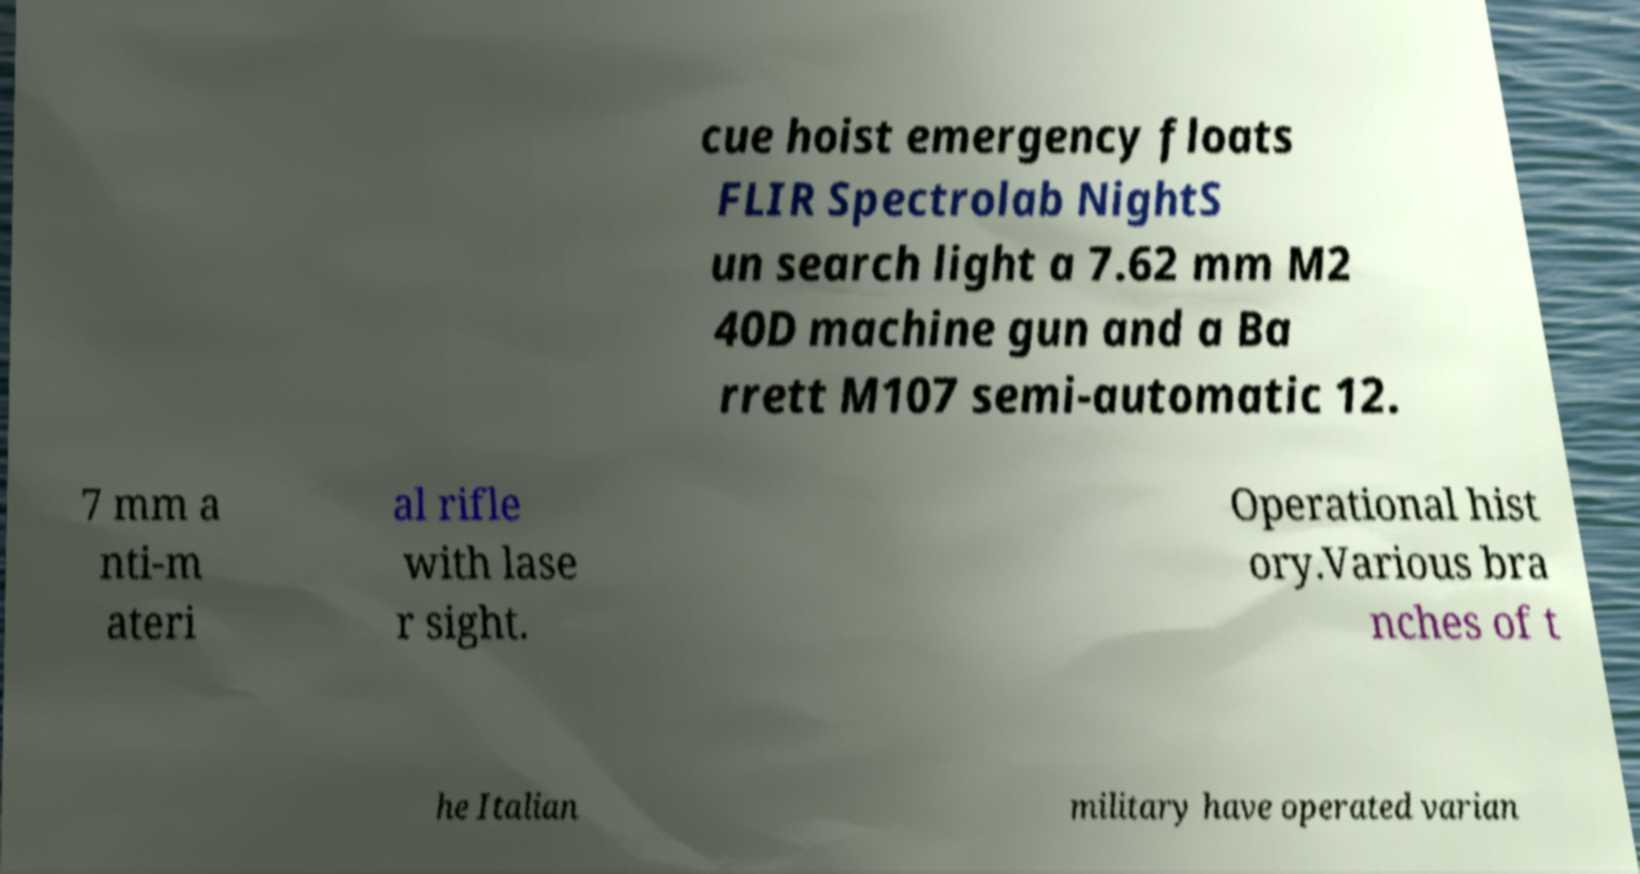What messages or text are displayed in this image? I need them in a readable, typed format. cue hoist emergency floats FLIR Spectrolab NightS un search light a 7.62 mm M2 40D machine gun and a Ba rrett M107 semi-automatic 12. 7 mm a nti-m ateri al rifle with lase r sight. Operational hist ory.Various bra nches of t he Italian military have operated varian 